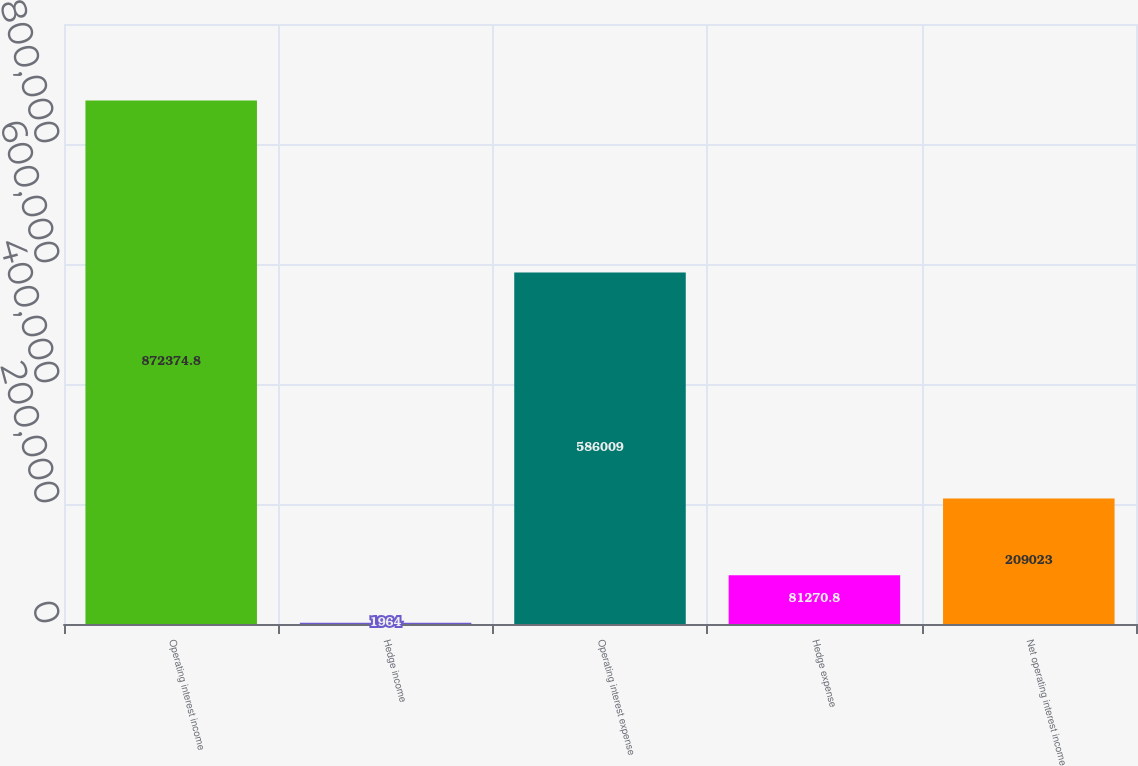Convert chart to OTSL. <chart><loc_0><loc_0><loc_500><loc_500><bar_chart><fcel>Operating interest income<fcel>Hedge income<fcel>Operating interest expense<fcel>Hedge expense<fcel>Net operating interest income<nl><fcel>872375<fcel>1964<fcel>586009<fcel>81270.8<fcel>209023<nl></chart> 